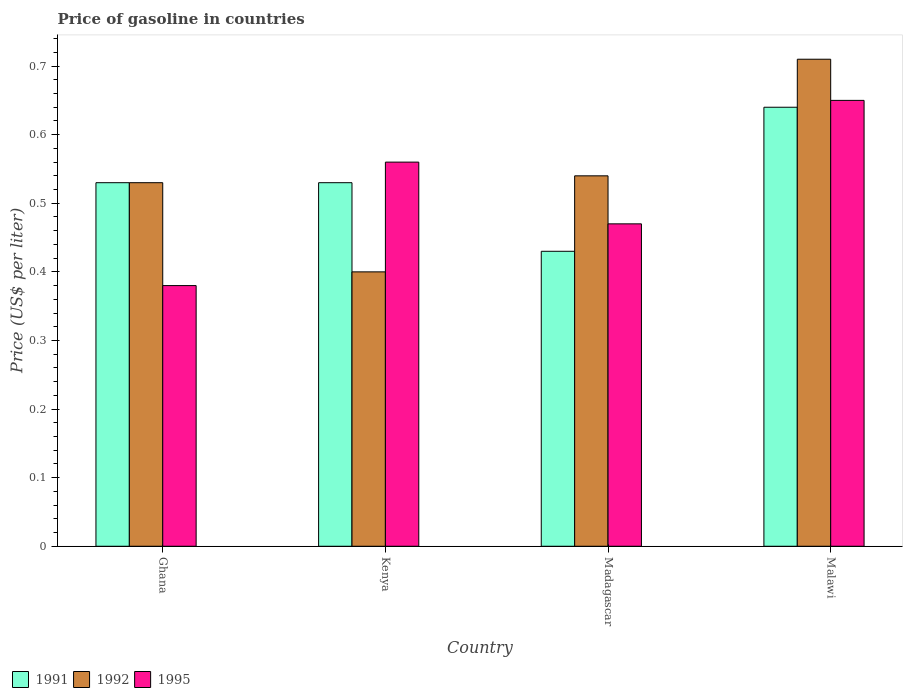How many groups of bars are there?
Make the answer very short. 4. Are the number of bars per tick equal to the number of legend labels?
Ensure brevity in your answer.  Yes. Are the number of bars on each tick of the X-axis equal?
Make the answer very short. Yes. How many bars are there on the 2nd tick from the left?
Your answer should be very brief. 3. How many bars are there on the 3rd tick from the right?
Your answer should be compact. 3. What is the label of the 4th group of bars from the left?
Make the answer very short. Malawi. What is the price of gasoline in 1992 in Madagascar?
Make the answer very short. 0.54. Across all countries, what is the maximum price of gasoline in 1991?
Give a very brief answer. 0.64. Across all countries, what is the minimum price of gasoline in 1991?
Ensure brevity in your answer.  0.43. In which country was the price of gasoline in 1991 maximum?
Offer a terse response. Malawi. In which country was the price of gasoline in 1995 minimum?
Your response must be concise. Ghana. What is the total price of gasoline in 1991 in the graph?
Offer a terse response. 2.13. What is the difference between the price of gasoline in 1992 in Ghana and that in Kenya?
Your answer should be very brief. 0.13. What is the difference between the price of gasoline in 1991 in Ghana and the price of gasoline in 1992 in Malawi?
Offer a very short reply. -0.18. What is the average price of gasoline in 1995 per country?
Keep it short and to the point. 0.52. What is the difference between the price of gasoline of/in 1991 and price of gasoline of/in 1995 in Madagascar?
Make the answer very short. -0.04. What is the ratio of the price of gasoline in 1991 in Ghana to that in Madagascar?
Make the answer very short. 1.23. Is the price of gasoline in 1992 in Kenya less than that in Malawi?
Provide a succinct answer. Yes. Is the difference between the price of gasoline in 1991 in Ghana and Kenya greater than the difference between the price of gasoline in 1995 in Ghana and Kenya?
Your answer should be very brief. Yes. What is the difference between the highest and the second highest price of gasoline in 1991?
Your response must be concise. 0.11. What is the difference between the highest and the lowest price of gasoline in 1995?
Offer a terse response. 0.27. Is the sum of the price of gasoline in 1995 in Kenya and Malawi greater than the maximum price of gasoline in 1992 across all countries?
Offer a terse response. Yes. What does the 2nd bar from the left in Ghana represents?
Your response must be concise. 1992. What does the 3rd bar from the right in Madagascar represents?
Offer a terse response. 1991. How many bars are there?
Give a very brief answer. 12. What is the difference between two consecutive major ticks on the Y-axis?
Offer a terse response. 0.1. Does the graph contain any zero values?
Provide a short and direct response. No. Does the graph contain grids?
Your response must be concise. No. How are the legend labels stacked?
Offer a very short reply. Horizontal. What is the title of the graph?
Your answer should be very brief. Price of gasoline in countries. What is the label or title of the Y-axis?
Offer a very short reply. Price (US$ per liter). What is the Price (US$ per liter) of 1991 in Ghana?
Make the answer very short. 0.53. What is the Price (US$ per liter) in 1992 in Ghana?
Ensure brevity in your answer.  0.53. What is the Price (US$ per liter) in 1995 in Ghana?
Your response must be concise. 0.38. What is the Price (US$ per liter) in 1991 in Kenya?
Give a very brief answer. 0.53. What is the Price (US$ per liter) in 1992 in Kenya?
Your answer should be compact. 0.4. What is the Price (US$ per liter) in 1995 in Kenya?
Make the answer very short. 0.56. What is the Price (US$ per liter) of 1991 in Madagascar?
Ensure brevity in your answer.  0.43. What is the Price (US$ per liter) of 1992 in Madagascar?
Provide a succinct answer. 0.54. What is the Price (US$ per liter) of 1995 in Madagascar?
Your answer should be compact. 0.47. What is the Price (US$ per liter) of 1991 in Malawi?
Offer a terse response. 0.64. What is the Price (US$ per liter) in 1992 in Malawi?
Give a very brief answer. 0.71. What is the Price (US$ per liter) in 1995 in Malawi?
Give a very brief answer. 0.65. Across all countries, what is the maximum Price (US$ per liter) of 1991?
Ensure brevity in your answer.  0.64. Across all countries, what is the maximum Price (US$ per liter) in 1992?
Make the answer very short. 0.71. Across all countries, what is the maximum Price (US$ per liter) in 1995?
Ensure brevity in your answer.  0.65. Across all countries, what is the minimum Price (US$ per liter) in 1991?
Your response must be concise. 0.43. Across all countries, what is the minimum Price (US$ per liter) of 1995?
Ensure brevity in your answer.  0.38. What is the total Price (US$ per liter) of 1991 in the graph?
Offer a terse response. 2.13. What is the total Price (US$ per liter) of 1992 in the graph?
Offer a very short reply. 2.18. What is the total Price (US$ per liter) in 1995 in the graph?
Your response must be concise. 2.06. What is the difference between the Price (US$ per liter) in 1992 in Ghana and that in Kenya?
Give a very brief answer. 0.13. What is the difference between the Price (US$ per liter) in 1995 in Ghana and that in Kenya?
Your response must be concise. -0.18. What is the difference between the Price (US$ per liter) of 1991 in Ghana and that in Madagascar?
Provide a succinct answer. 0.1. What is the difference between the Price (US$ per liter) of 1992 in Ghana and that in Madagascar?
Give a very brief answer. -0.01. What is the difference between the Price (US$ per liter) in 1995 in Ghana and that in Madagascar?
Your answer should be compact. -0.09. What is the difference between the Price (US$ per liter) of 1991 in Ghana and that in Malawi?
Offer a very short reply. -0.11. What is the difference between the Price (US$ per liter) in 1992 in Ghana and that in Malawi?
Provide a succinct answer. -0.18. What is the difference between the Price (US$ per liter) of 1995 in Ghana and that in Malawi?
Your answer should be compact. -0.27. What is the difference between the Price (US$ per liter) of 1992 in Kenya and that in Madagascar?
Provide a short and direct response. -0.14. What is the difference between the Price (US$ per liter) in 1995 in Kenya and that in Madagascar?
Your answer should be very brief. 0.09. What is the difference between the Price (US$ per liter) of 1991 in Kenya and that in Malawi?
Offer a very short reply. -0.11. What is the difference between the Price (US$ per liter) in 1992 in Kenya and that in Malawi?
Offer a terse response. -0.31. What is the difference between the Price (US$ per liter) of 1995 in Kenya and that in Malawi?
Provide a succinct answer. -0.09. What is the difference between the Price (US$ per liter) of 1991 in Madagascar and that in Malawi?
Your answer should be very brief. -0.21. What is the difference between the Price (US$ per liter) of 1992 in Madagascar and that in Malawi?
Offer a very short reply. -0.17. What is the difference between the Price (US$ per liter) of 1995 in Madagascar and that in Malawi?
Your answer should be compact. -0.18. What is the difference between the Price (US$ per liter) of 1991 in Ghana and the Price (US$ per liter) of 1992 in Kenya?
Offer a terse response. 0.13. What is the difference between the Price (US$ per liter) of 1991 in Ghana and the Price (US$ per liter) of 1995 in Kenya?
Give a very brief answer. -0.03. What is the difference between the Price (US$ per liter) of 1992 in Ghana and the Price (US$ per liter) of 1995 in Kenya?
Give a very brief answer. -0.03. What is the difference between the Price (US$ per liter) in 1991 in Ghana and the Price (US$ per liter) in 1992 in Madagascar?
Keep it short and to the point. -0.01. What is the difference between the Price (US$ per liter) of 1991 in Ghana and the Price (US$ per liter) of 1995 in Madagascar?
Offer a terse response. 0.06. What is the difference between the Price (US$ per liter) in 1992 in Ghana and the Price (US$ per liter) in 1995 in Madagascar?
Provide a succinct answer. 0.06. What is the difference between the Price (US$ per liter) of 1991 in Ghana and the Price (US$ per liter) of 1992 in Malawi?
Make the answer very short. -0.18. What is the difference between the Price (US$ per liter) of 1991 in Ghana and the Price (US$ per liter) of 1995 in Malawi?
Your response must be concise. -0.12. What is the difference between the Price (US$ per liter) in 1992 in Ghana and the Price (US$ per liter) in 1995 in Malawi?
Your answer should be very brief. -0.12. What is the difference between the Price (US$ per liter) in 1991 in Kenya and the Price (US$ per liter) in 1992 in Madagascar?
Ensure brevity in your answer.  -0.01. What is the difference between the Price (US$ per liter) in 1991 in Kenya and the Price (US$ per liter) in 1995 in Madagascar?
Give a very brief answer. 0.06. What is the difference between the Price (US$ per liter) of 1992 in Kenya and the Price (US$ per liter) of 1995 in Madagascar?
Your answer should be very brief. -0.07. What is the difference between the Price (US$ per liter) of 1991 in Kenya and the Price (US$ per liter) of 1992 in Malawi?
Offer a terse response. -0.18. What is the difference between the Price (US$ per liter) in 1991 in Kenya and the Price (US$ per liter) in 1995 in Malawi?
Offer a very short reply. -0.12. What is the difference between the Price (US$ per liter) in 1992 in Kenya and the Price (US$ per liter) in 1995 in Malawi?
Make the answer very short. -0.25. What is the difference between the Price (US$ per liter) in 1991 in Madagascar and the Price (US$ per liter) in 1992 in Malawi?
Make the answer very short. -0.28. What is the difference between the Price (US$ per liter) of 1991 in Madagascar and the Price (US$ per liter) of 1995 in Malawi?
Provide a short and direct response. -0.22. What is the difference between the Price (US$ per liter) in 1992 in Madagascar and the Price (US$ per liter) in 1995 in Malawi?
Keep it short and to the point. -0.11. What is the average Price (US$ per liter) in 1991 per country?
Your answer should be very brief. 0.53. What is the average Price (US$ per liter) in 1992 per country?
Make the answer very short. 0.55. What is the average Price (US$ per liter) in 1995 per country?
Give a very brief answer. 0.52. What is the difference between the Price (US$ per liter) of 1992 and Price (US$ per liter) of 1995 in Ghana?
Keep it short and to the point. 0.15. What is the difference between the Price (US$ per liter) in 1991 and Price (US$ per liter) in 1992 in Kenya?
Ensure brevity in your answer.  0.13. What is the difference between the Price (US$ per liter) of 1991 and Price (US$ per liter) of 1995 in Kenya?
Provide a succinct answer. -0.03. What is the difference between the Price (US$ per liter) of 1992 and Price (US$ per liter) of 1995 in Kenya?
Make the answer very short. -0.16. What is the difference between the Price (US$ per liter) in 1991 and Price (US$ per liter) in 1992 in Madagascar?
Your answer should be very brief. -0.11. What is the difference between the Price (US$ per liter) in 1991 and Price (US$ per liter) in 1995 in Madagascar?
Provide a short and direct response. -0.04. What is the difference between the Price (US$ per liter) of 1992 and Price (US$ per liter) of 1995 in Madagascar?
Give a very brief answer. 0.07. What is the difference between the Price (US$ per liter) in 1991 and Price (US$ per liter) in 1992 in Malawi?
Make the answer very short. -0.07. What is the difference between the Price (US$ per liter) of 1991 and Price (US$ per liter) of 1995 in Malawi?
Provide a succinct answer. -0.01. What is the ratio of the Price (US$ per liter) in 1991 in Ghana to that in Kenya?
Provide a short and direct response. 1. What is the ratio of the Price (US$ per liter) in 1992 in Ghana to that in Kenya?
Offer a terse response. 1.32. What is the ratio of the Price (US$ per liter) of 1995 in Ghana to that in Kenya?
Your response must be concise. 0.68. What is the ratio of the Price (US$ per liter) in 1991 in Ghana to that in Madagascar?
Your answer should be very brief. 1.23. What is the ratio of the Price (US$ per liter) of 1992 in Ghana to that in Madagascar?
Give a very brief answer. 0.98. What is the ratio of the Price (US$ per liter) in 1995 in Ghana to that in Madagascar?
Provide a short and direct response. 0.81. What is the ratio of the Price (US$ per liter) in 1991 in Ghana to that in Malawi?
Your response must be concise. 0.83. What is the ratio of the Price (US$ per liter) in 1992 in Ghana to that in Malawi?
Provide a succinct answer. 0.75. What is the ratio of the Price (US$ per liter) in 1995 in Ghana to that in Malawi?
Make the answer very short. 0.58. What is the ratio of the Price (US$ per liter) in 1991 in Kenya to that in Madagascar?
Make the answer very short. 1.23. What is the ratio of the Price (US$ per liter) of 1992 in Kenya to that in Madagascar?
Make the answer very short. 0.74. What is the ratio of the Price (US$ per liter) in 1995 in Kenya to that in Madagascar?
Provide a succinct answer. 1.19. What is the ratio of the Price (US$ per liter) of 1991 in Kenya to that in Malawi?
Make the answer very short. 0.83. What is the ratio of the Price (US$ per liter) in 1992 in Kenya to that in Malawi?
Your answer should be compact. 0.56. What is the ratio of the Price (US$ per liter) in 1995 in Kenya to that in Malawi?
Your answer should be very brief. 0.86. What is the ratio of the Price (US$ per liter) in 1991 in Madagascar to that in Malawi?
Your answer should be very brief. 0.67. What is the ratio of the Price (US$ per liter) of 1992 in Madagascar to that in Malawi?
Keep it short and to the point. 0.76. What is the ratio of the Price (US$ per liter) of 1995 in Madagascar to that in Malawi?
Offer a very short reply. 0.72. What is the difference between the highest and the second highest Price (US$ per liter) in 1991?
Ensure brevity in your answer.  0.11. What is the difference between the highest and the second highest Price (US$ per liter) in 1992?
Provide a succinct answer. 0.17. What is the difference between the highest and the second highest Price (US$ per liter) of 1995?
Provide a short and direct response. 0.09. What is the difference between the highest and the lowest Price (US$ per liter) in 1991?
Offer a terse response. 0.21. What is the difference between the highest and the lowest Price (US$ per liter) in 1992?
Provide a short and direct response. 0.31. What is the difference between the highest and the lowest Price (US$ per liter) of 1995?
Your answer should be compact. 0.27. 